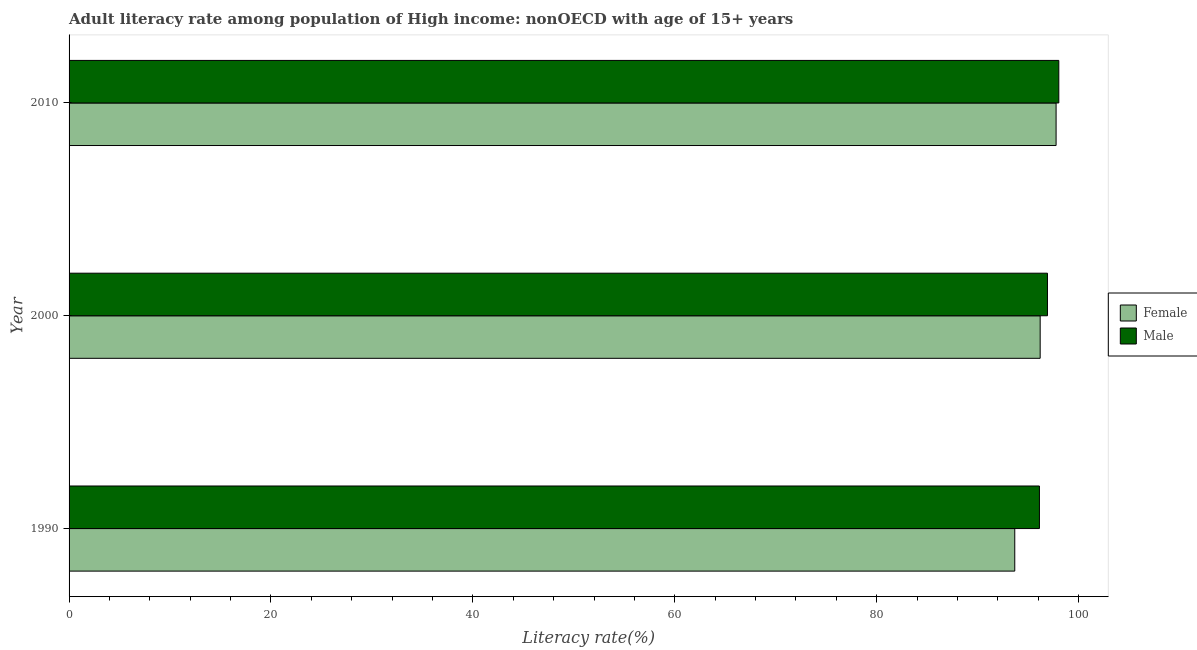How many different coloured bars are there?
Ensure brevity in your answer.  2. Are the number of bars per tick equal to the number of legend labels?
Your answer should be compact. Yes. Are the number of bars on each tick of the Y-axis equal?
Your response must be concise. Yes. How many bars are there on the 1st tick from the bottom?
Make the answer very short. 2. In how many cases, is the number of bars for a given year not equal to the number of legend labels?
Your response must be concise. 0. What is the female adult literacy rate in 2000?
Keep it short and to the point. 96.19. Across all years, what is the maximum female adult literacy rate?
Your answer should be very brief. 97.77. Across all years, what is the minimum female adult literacy rate?
Offer a very short reply. 93.67. What is the total male adult literacy rate in the graph?
Your answer should be compact. 291.07. What is the difference between the female adult literacy rate in 1990 and that in 2000?
Make the answer very short. -2.52. What is the difference between the male adult literacy rate in 2000 and the female adult literacy rate in 2010?
Provide a succinct answer. -0.85. What is the average female adult literacy rate per year?
Your answer should be compact. 95.88. In the year 1990, what is the difference between the male adult literacy rate and female adult literacy rate?
Provide a succinct answer. 2.44. In how many years, is the female adult literacy rate greater than 52 %?
Ensure brevity in your answer.  3. What is the ratio of the female adult literacy rate in 1990 to that in 2010?
Give a very brief answer. 0.96. What is the difference between the highest and the second highest female adult literacy rate?
Your response must be concise. 1.58. What is the difference between the highest and the lowest male adult literacy rate?
Your answer should be compact. 1.92. Is the sum of the female adult literacy rate in 1990 and 2010 greater than the maximum male adult literacy rate across all years?
Make the answer very short. Yes. What does the 2nd bar from the top in 1990 represents?
Ensure brevity in your answer.  Female. How many years are there in the graph?
Provide a short and direct response. 3. Does the graph contain any zero values?
Offer a terse response. No. How are the legend labels stacked?
Your answer should be compact. Vertical. What is the title of the graph?
Provide a short and direct response. Adult literacy rate among population of High income: nonOECD with age of 15+ years. What is the label or title of the X-axis?
Provide a succinct answer. Literacy rate(%). What is the label or title of the Y-axis?
Ensure brevity in your answer.  Year. What is the Literacy rate(%) of Female in 1990?
Offer a very short reply. 93.67. What is the Literacy rate(%) in Male in 1990?
Give a very brief answer. 96.12. What is the Literacy rate(%) of Female in 2000?
Your answer should be very brief. 96.19. What is the Literacy rate(%) in Male in 2000?
Make the answer very short. 96.91. What is the Literacy rate(%) in Female in 2010?
Offer a very short reply. 97.77. What is the Literacy rate(%) in Male in 2010?
Give a very brief answer. 98.04. Across all years, what is the maximum Literacy rate(%) of Female?
Your answer should be compact. 97.77. Across all years, what is the maximum Literacy rate(%) of Male?
Your answer should be compact. 98.04. Across all years, what is the minimum Literacy rate(%) in Female?
Provide a succinct answer. 93.67. Across all years, what is the minimum Literacy rate(%) in Male?
Your response must be concise. 96.12. What is the total Literacy rate(%) of Female in the graph?
Offer a terse response. 287.63. What is the total Literacy rate(%) of Male in the graph?
Keep it short and to the point. 291.07. What is the difference between the Literacy rate(%) in Female in 1990 and that in 2000?
Your answer should be very brief. -2.52. What is the difference between the Literacy rate(%) of Male in 1990 and that in 2000?
Your response must be concise. -0.8. What is the difference between the Literacy rate(%) of Female in 1990 and that in 2010?
Provide a succinct answer. -4.09. What is the difference between the Literacy rate(%) in Male in 1990 and that in 2010?
Offer a terse response. -1.92. What is the difference between the Literacy rate(%) in Female in 2000 and that in 2010?
Keep it short and to the point. -1.58. What is the difference between the Literacy rate(%) of Male in 2000 and that in 2010?
Provide a succinct answer. -1.12. What is the difference between the Literacy rate(%) of Female in 1990 and the Literacy rate(%) of Male in 2000?
Your response must be concise. -3.24. What is the difference between the Literacy rate(%) in Female in 1990 and the Literacy rate(%) in Male in 2010?
Offer a terse response. -4.36. What is the difference between the Literacy rate(%) of Female in 2000 and the Literacy rate(%) of Male in 2010?
Provide a short and direct response. -1.85. What is the average Literacy rate(%) of Female per year?
Make the answer very short. 95.88. What is the average Literacy rate(%) of Male per year?
Keep it short and to the point. 97.02. In the year 1990, what is the difference between the Literacy rate(%) in Female and Literacy rate(%) in Male?
Make the answer very short. -2.44. In the year 2000, what is the difference between the Literacy rate(%) of Female and Literacy rate(%) of Male?
Your answer should be very brief. -0.72. In the year 2010, what is the difference between the Literacy rate(%) in Female and Literacy rate(%) in Male?
Give a very brief answer. -0.27. What is the ratio of the Literacy rate(%) of Female in 1990 to that in 2000?
Offer a terse response. 0.97. What is the ratio of the Literacy rate(%) of Male in 1990 to that in 2000?
Your answer should be very brief. 0.99. What is the ratio of the Literacy rate(%) of Female in 1990 to that in 2010?
Offer a terse response. 0.96. What is the ratio of the Literacy rate(%) in Male in 1990 to that in 2010?
Your answer should be compact. 0.98. What is the ratio of the Literacy rate(%) of Female in 2000 to that in 2010?
Provide a succinct answer. 0.98. What is the ratio of the Literacy rate(%) in Male in 2000 to that in 2010?
Make the answer very short. 0.99. What is the difference between the highest and the second highest Literacy rate(%) in Female?
Make the answer very short. 1.58. What is the difference between the highest and the second highest Literacy rate(%) in Male?
Your answer should be compact. 1.12. What is the difference between the highest and the lowest Literacy rate(%) of Female?
Keep it short and to the point. 4.09. What is the difference between the highest and the lowest Literacy rate(%) in Male?
Keep it short and to the point. 1.92. 